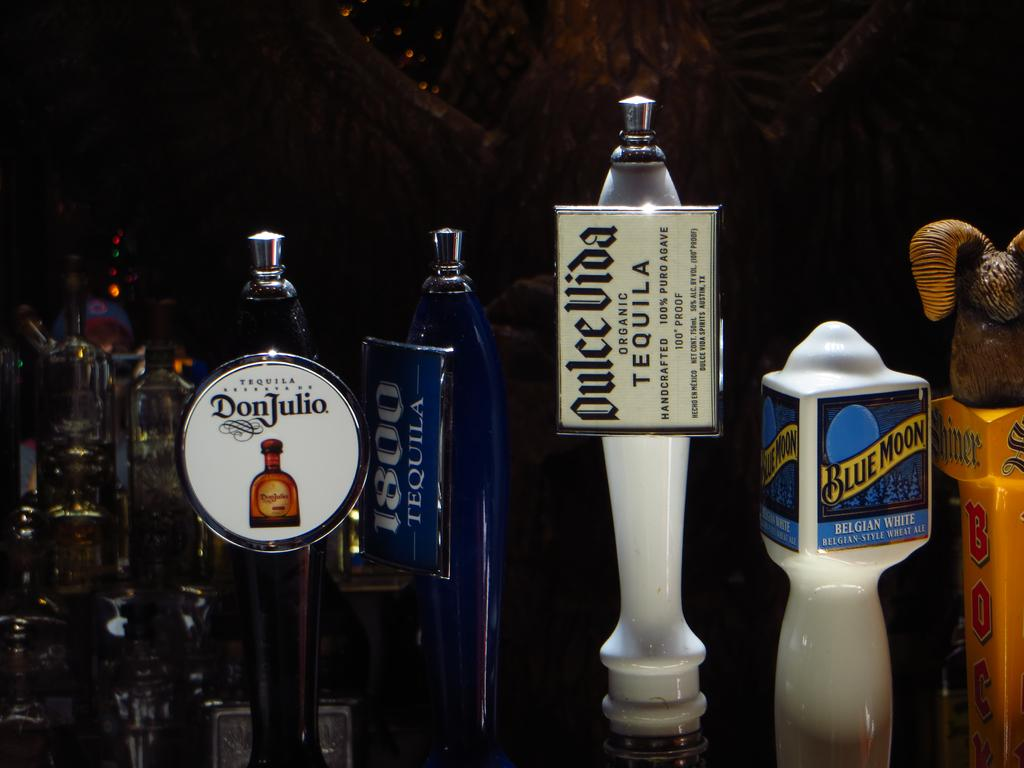Provide a one-sentence caption for the provided image. Four beer pumps are seen close up including Blue Moon, DonJulio, 1800 Tequila and others. 